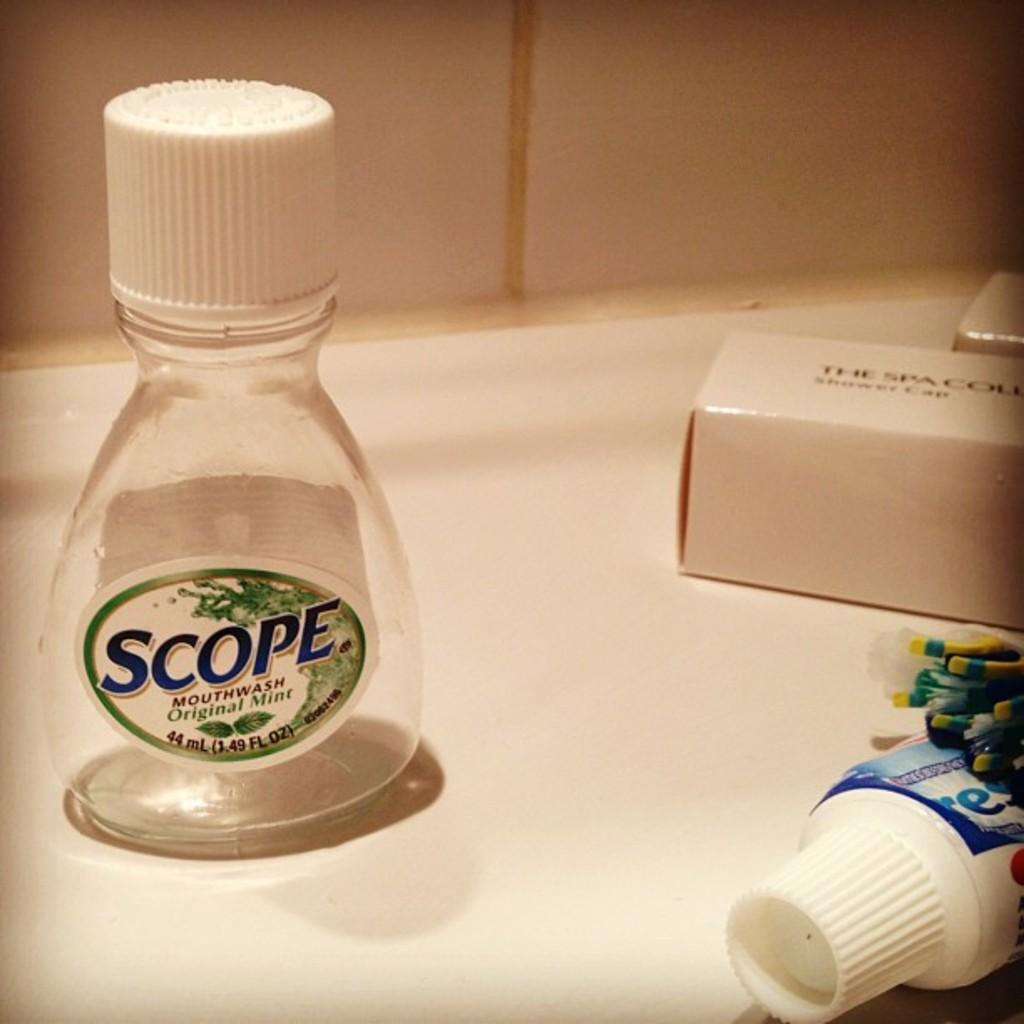What type of product is featured in the image? There is a mouthwash bottle in the image. What color is the lid of the mouthwash bottle? The mouthwash bottle has a white lid. What other bathroom-related item can be seen in the image? There is a shower cap box in the image. What type of grape is featured in the image? There are no grapes present in the image; it features a mouthwash bottle and a shower cap box. What type of art can be seen on the shower cap box? There is no art visible on the shower cap box in the image. 